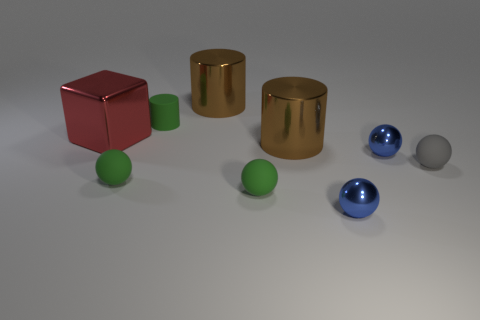Subtract all gray spheres. How many spheres are left? 4 Subtract all gray spheres. How many spheres are left? 4 Subtract all yellow balls. Subtract all red cubes. How many balls are left? 5 Subtract all blocks. How many objects are left? 8 Subtract all big blue rubber cylinders. Subtract all tiny gray spheres. How many objects are left? 8 Add 5 tiny green spheres. How many tiny green spheres are left? 7 Add 8 small gray balls. How many small gray balls exist? 9 Subtract 0 gray cubes. How many objects are left? 9 